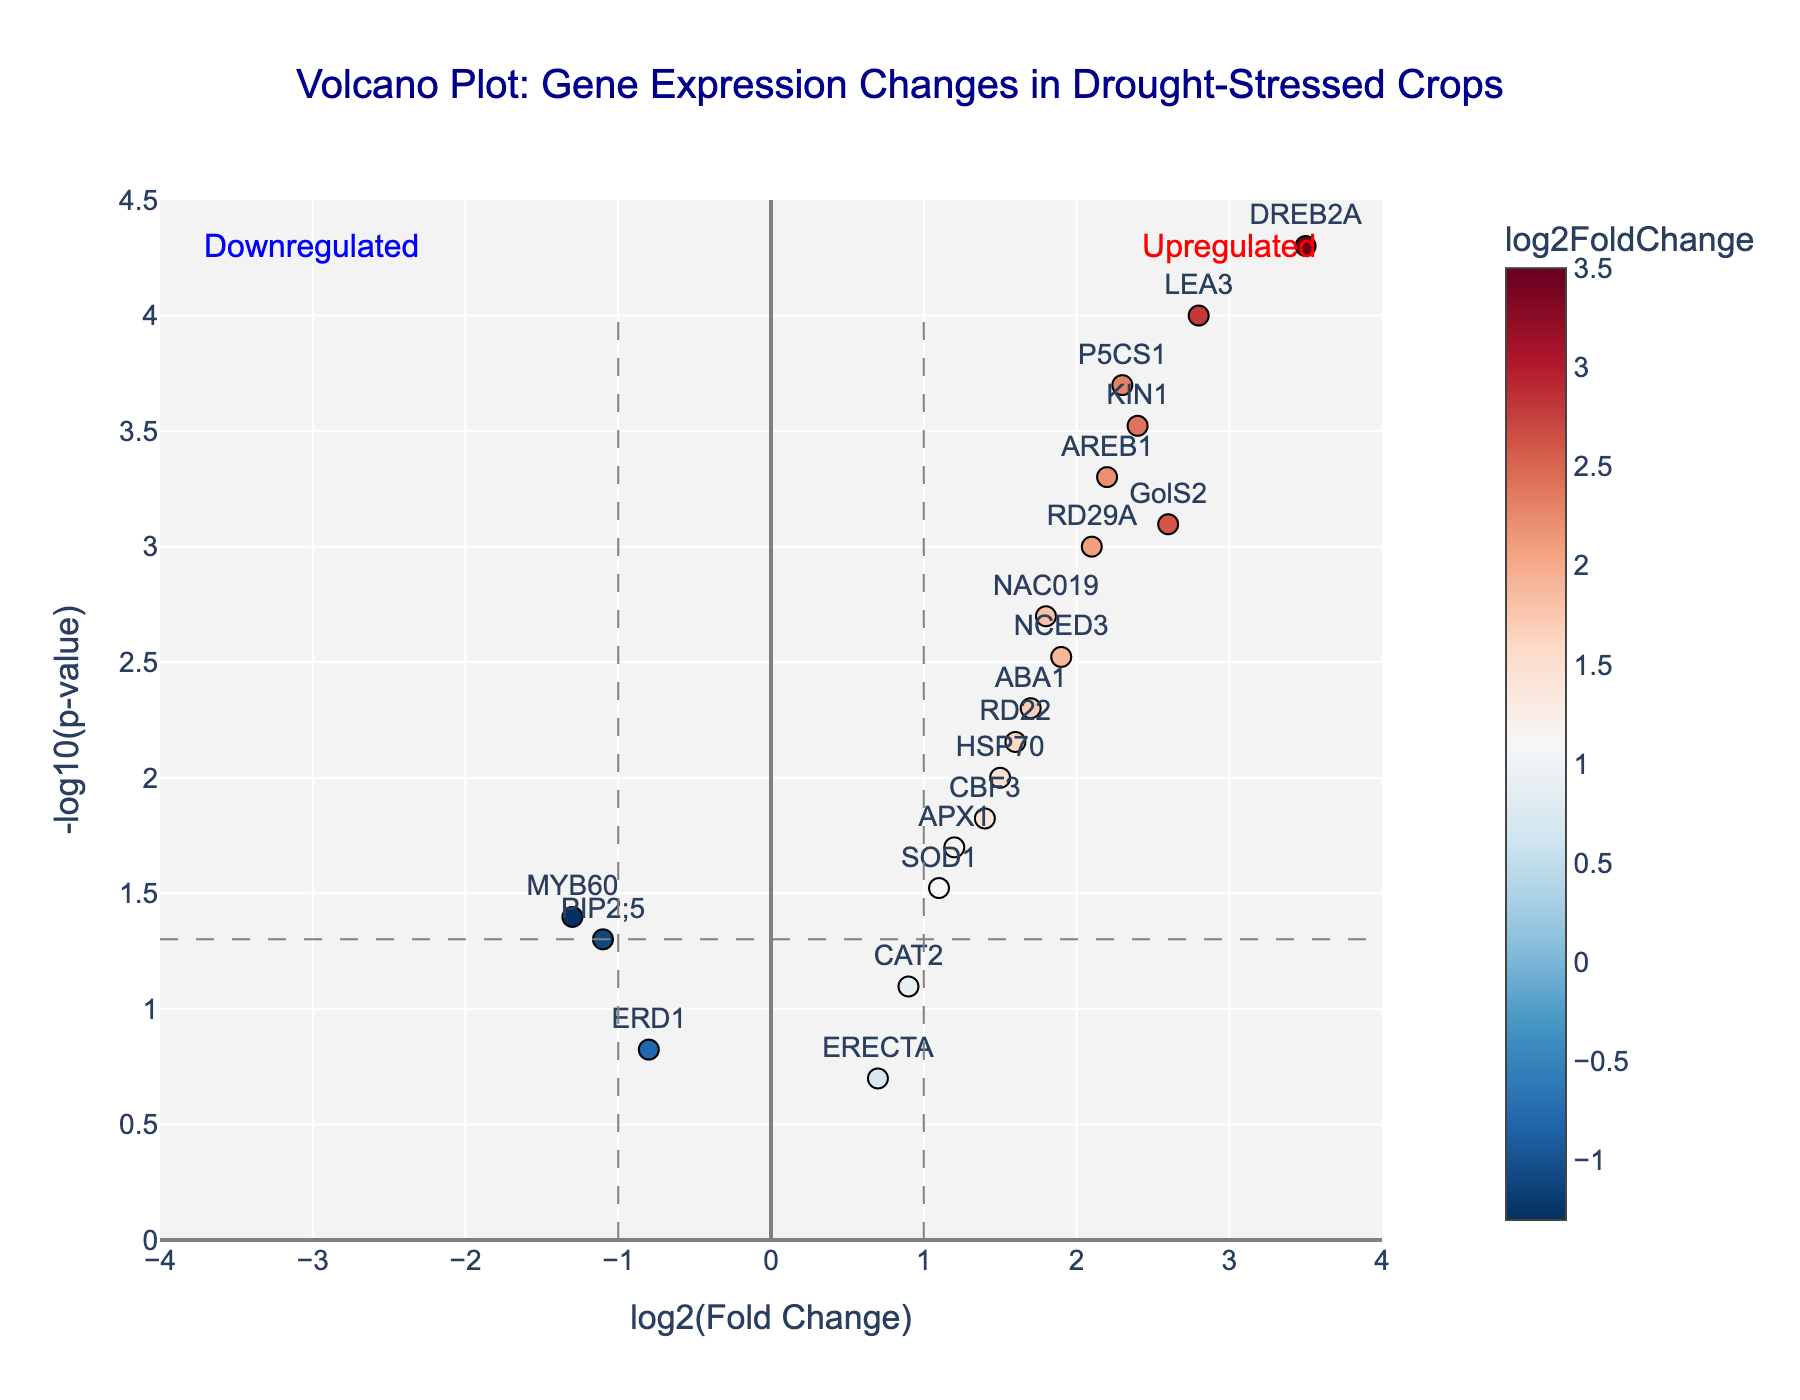What is the title of the plot? The title is located at the top of the plot, centrally aligned, and it reads: "Volcano Plot: Gene Expression Changes in Drought-Stressed Crops".
Answer: Volcano Plot: Gene Expression Changes in Drought-Stressed Crops Which gene has the highest log2(Fold Change) under drought stress? To find the gene with the highest log2(Fold Change), look for the marker that is the farthest to the right. According to the hovertext and positioning, the gene DREB2A has the highest log2(Fold Change) of 3.5.
Answer: DREB2A How many genes fall below the horizontal grey dashed line at -log10(p-value) = 1.3 (which corresponds to p-value = 0.05)? The horizontal line at -log10(p-value) = 1.3 separates genes with p-values greater than 0.05 from those with smaller p-values. Counting the markers below this line, we find three such genes: CAT2, ERECTA, and ERD1.
Answer: 3 What is the log2(Fold Change) range of genes that are significantly upregulated (p-value < 0.05)? First, identify genes above the horizontal grey dashed line. Among those, the upregulated genes will have log2(Fold Change) > 0. The relevant genes are LEA3, DREB2A, RD29A, NCED3, P5CS1, ABA1, GolS2, NAC019, AREB1, RD22, and KIN1. The log2(Fold Change) range for these genes is approximately between 1.7 and 3.5.
Answer: 1.7 to 3.5 Which genes are upregulated more than 2-fold and have a p-value less than 0.001? Upregulated genes will have log2(Fold Change) > 1, which corresponds to more than 2-fold change, and also fall above -log10(p-value) > 3 (p-value < 0.001). The relevant genes are LEA3, DREB2A, P5CS1, and AREB1.
Answer: LEA3, DREB2A, P5CS1, AREB1 Is the gene RD29A significantly differentially expressed under drought stress? Check if the RD29A gene is above the horizontal dashed line at -log10(p-value) = 1.3 (which corresponds to p-value = 0.05) to determine if it is significant. It is indeed above this threshold, making it significantly differentially expressed.
Answer: Yes Which gene has the lowest log2(Fold Change) and is still significantly differentially expressed? Identify the gene with the lowest log2(Fold Change) above the horizontal dashed line at -log10(p-value) = 1.3. The gene MYB60 has a log2(Fold Change) of -1.3 and is above this line, indicating significant differential expression.
Answer: MYB60 